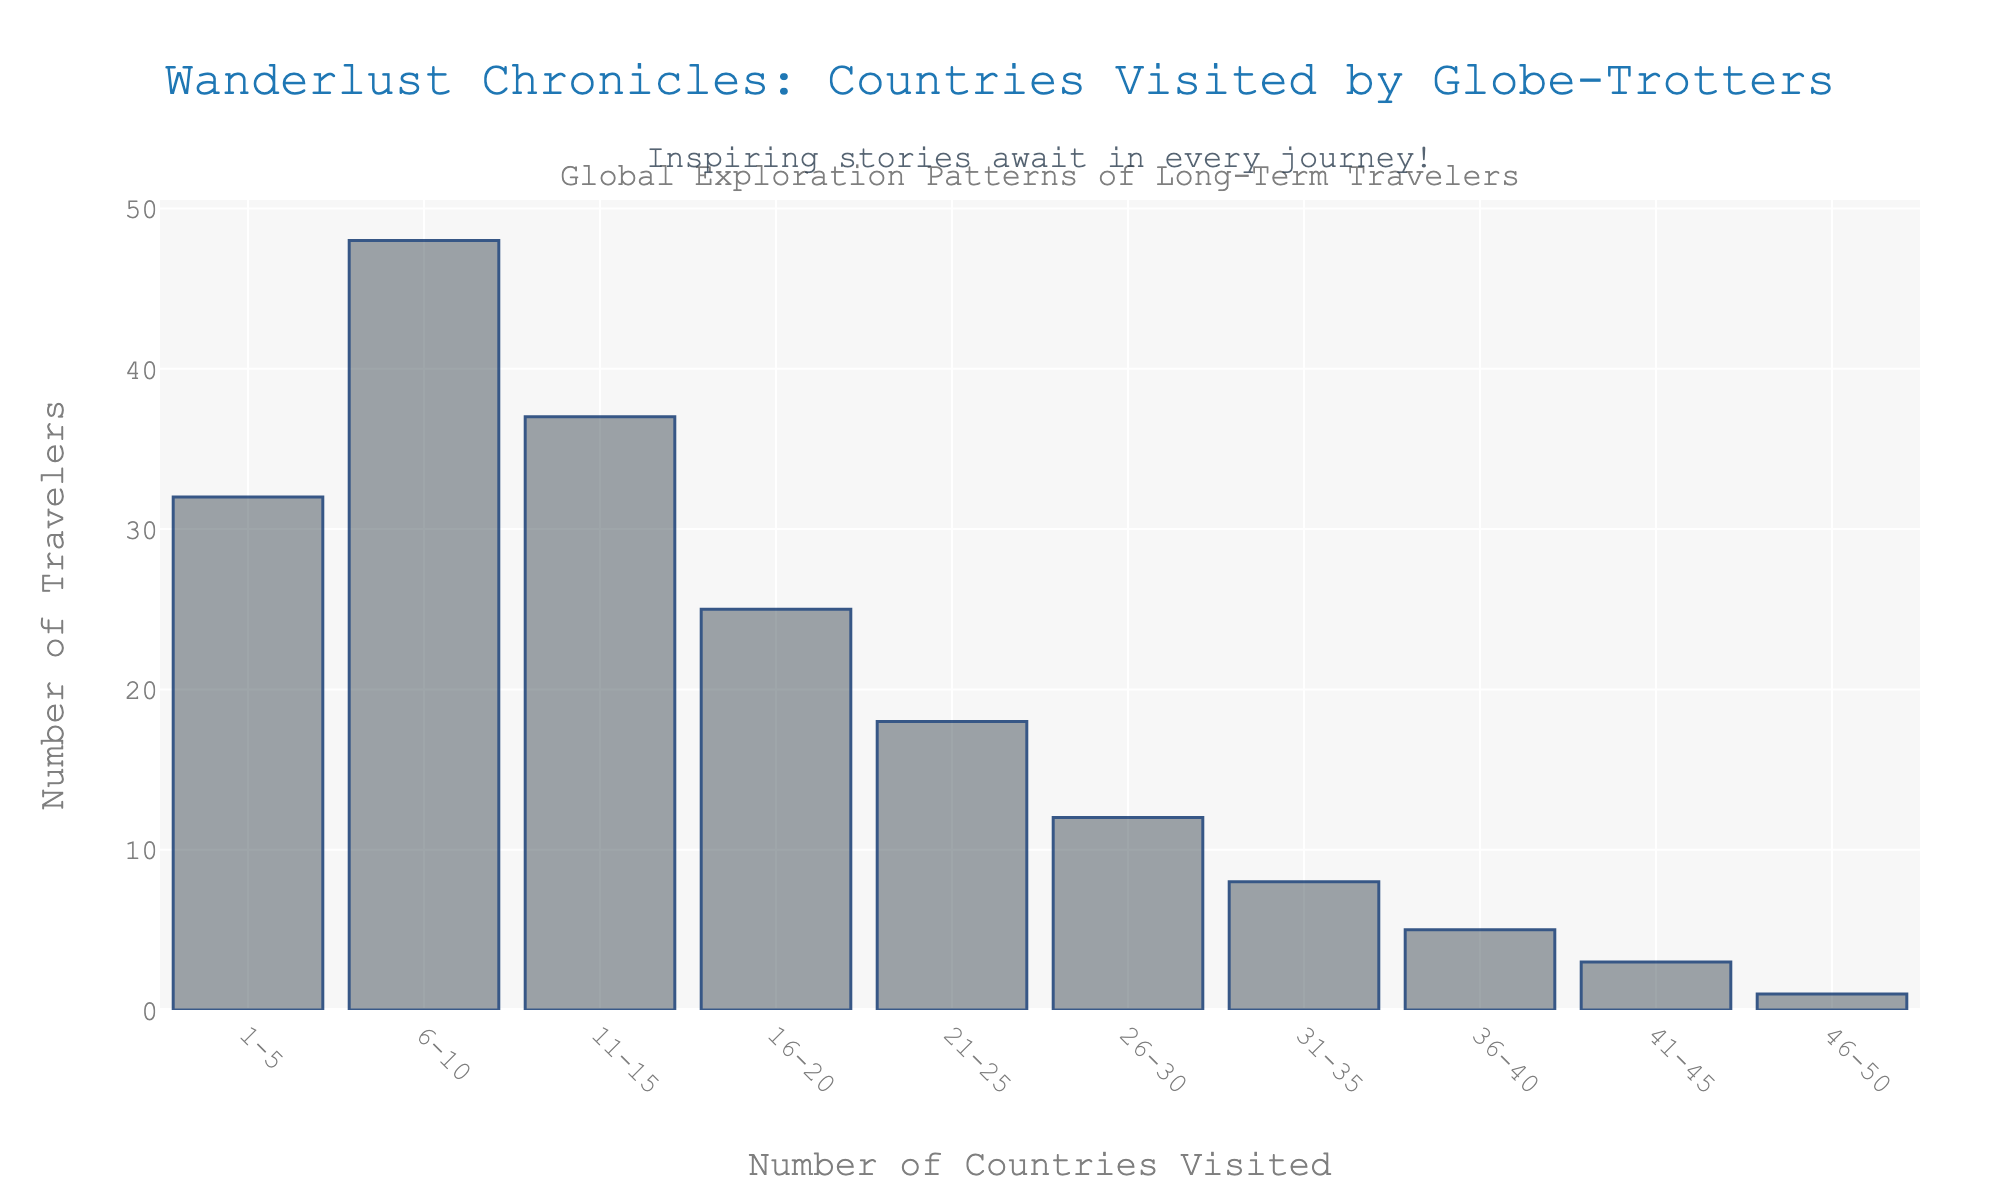What's the title of the figure? The title of the figure is usually found at the top and describes the contents or purpose of the chart. In this case, it reads "Wanderlust Chronicles: Countries Visited by Globe-Trotters."
Answer: Wanderlust Chronicles: Countries Visited by Globe-Trotters What is the range of countries most frequently visited by travelers? To determine the most frequently visited range, look for the bar with the highest value on the y-axis. Here, it corresponds to the x-axis label "6-10" with the highest y-value (48 travelers).
Answer: 6-10 How many travelers have visited more than 25 countries? Identify and sum the number of travelers in each range greater than 25 countries from the x-axis. These are 26-30 (12), 31-35 (8), 36-40 (5), 41-45 (3), and 46-50 (1). Adding these together: 12 + 8 + 5 + 3 + 1 = 29
Answer: 29 Which range has the second least number of travelers? Locate the bars with the least number of travelers and then find the second lowest. The smallest is 46-50 (1 traveler), and the second smallest is 41-45 with 3 travelers.
Answer: 41-45 How does the number of travelers visiting 11-15 countries compare to those visiting 1-5 countries? Compare the height of the bars corresponding to 11-15 and 1-5 on the x-axis. The bar for 11-15 has 37 travelers, while 1-5 has 32 travelers, meaning 11-15 has more.
Answer: 11-15 has more What's the total number of travelers represented in the figure? Sum the number of travelers for all ranges. Add 32 (1-5), 48 (6-10), 37 (11-15), 25 (16-20), 18 (21-25), 12 (26-30), 8 (31-35), 5 (36-40), 3 (41-45), and 1 (46-50): 32 + 48 + 37 + 25 + 18 + 12 + 8 + 5 + 3 + 1 = 189
Answer: 189 What's the difference in the number of travelers between 6-10 and 16-20 countries? Subtract the number of travelers in the 16-20 range (25) from those in the 6-10 range (48): 48 - 25 = 23
Answer: 23 What can be inferred about the correlation between the number of countries visited and the number of travelers? Observe the trend in the bar heights as the range of countries visited increases. Generally, as the number of countries visited increases, the number of travelers decreases.
Answer: Negative correlation 